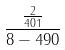Convert formula to latex. <formula><loc_0><loc_0><loc_500><loc_500>\frac { \frac { 2 } { 4 0 1 } } { 8 - 4 9 0 }</formula> 